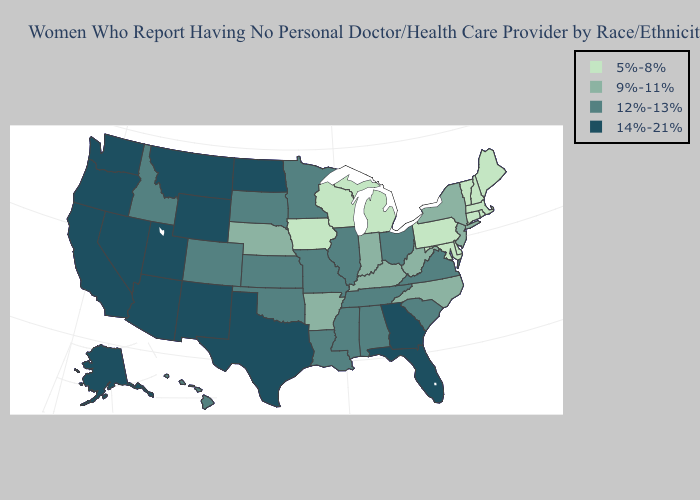Name the states that have a value in the range 5%-8%?
Answer briefly. Connecticut, Delaware, Iowa, Maine, Maryland, Massachusetts, Michigan, New Hampshire, Pennsylvania, Rhode Island, Vermont, Wisconsin. What is the lowest value in the MidWest?
Quick response, please. 5%-8%. Does Oklahoma have the same value as Vermont?
Keep it brief. No. Name the states that have a value in the range 14%-21%?
Keep it brief. Alaska, Arizona, California, Florida, Georgia, Montana, Nevada, New Mexico, North Dakota, Oregon, Texas, Utah, Washington, Wyoming. Does Colorado have the highest value in the USA?
Concise answer only. No. Which states have the highest value in the USA?
Answer briefly. Alaska, Arizona, California, Florida, Georgia, Montana, Nevada, New Mexico, North Dakota, Oregon, Texas, Utah, Washington, Wyoming. Name the states that have a value in the range 12%-13%?
Concise answer only. Alabama, Colorado, Hawaii, Idaho, Illinois, Kansas, Louisiana, Minnesota, Mississippi, Missouri, Ohio, Oklahoma, South Carolina, South Dakota, Tennessee, Virginia. What is the lowest value in the USA?
Write a very short answer. 5%-8%. What is the value of New Jersey?
Answer briefly. 9%-11%. Name the states that have a value in the range 14%-21%?
Be succinct. Alaska, Arizona, California, Florida, Georgia, Montana, Nevada, New Mexico, North Dakota, Oregon, Texas, Utah, Washington, Wyoming. What is the value of Iowa?
Give a very brief answer. 5%-8%. Which states have the lowest value in the Northeast?
Give a very brief answer. Connecticut, Maine, Massachusetts, New Hampshire, Pennsylvania, Rhode Island, Vermont. Does Arizona have the highest value in the West?
Write a very short answer. Yes. What is the value of California?
Give a very brief answer. 14%-21%. What is the highest value in states that border Maine?
Short answer required. 5%-8%. 